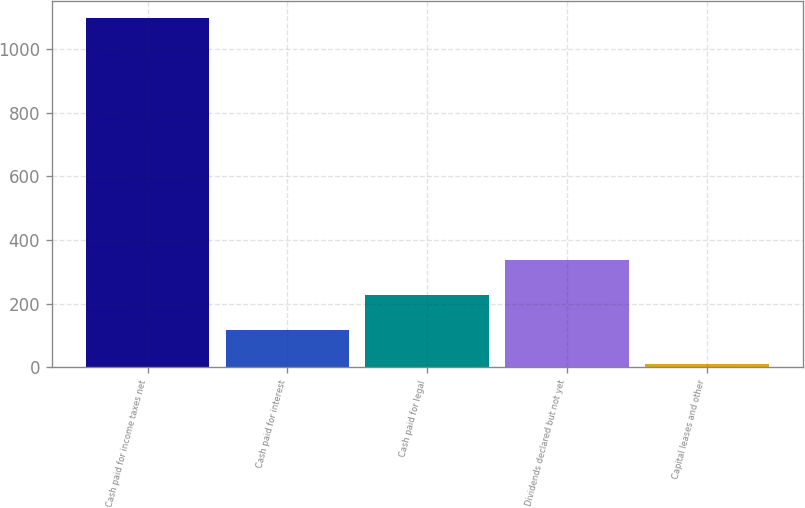Convert chart. <chart><loc_0><loc_0><loc_500><loc_500><bar_chart><fcel>Cash paid for income taxes net<fcel>Cash paid for interest<fcel>Cash paid for legal<fcel>Dividends declared but not yet<fcel>Capital leases and other<nl><fcel>1097<fcel>118.7<fcel>227.4<fcel>336.1<fcel>10<nl></chart> 